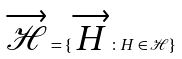Convert formula to latex. <formula><loc_0><loc_0><loc_500><loc_500>\overrightarrow { \mathcal { H } } = \{ \overrightarrow { H } \colon H \in \mathcal { H } \}</formula> 